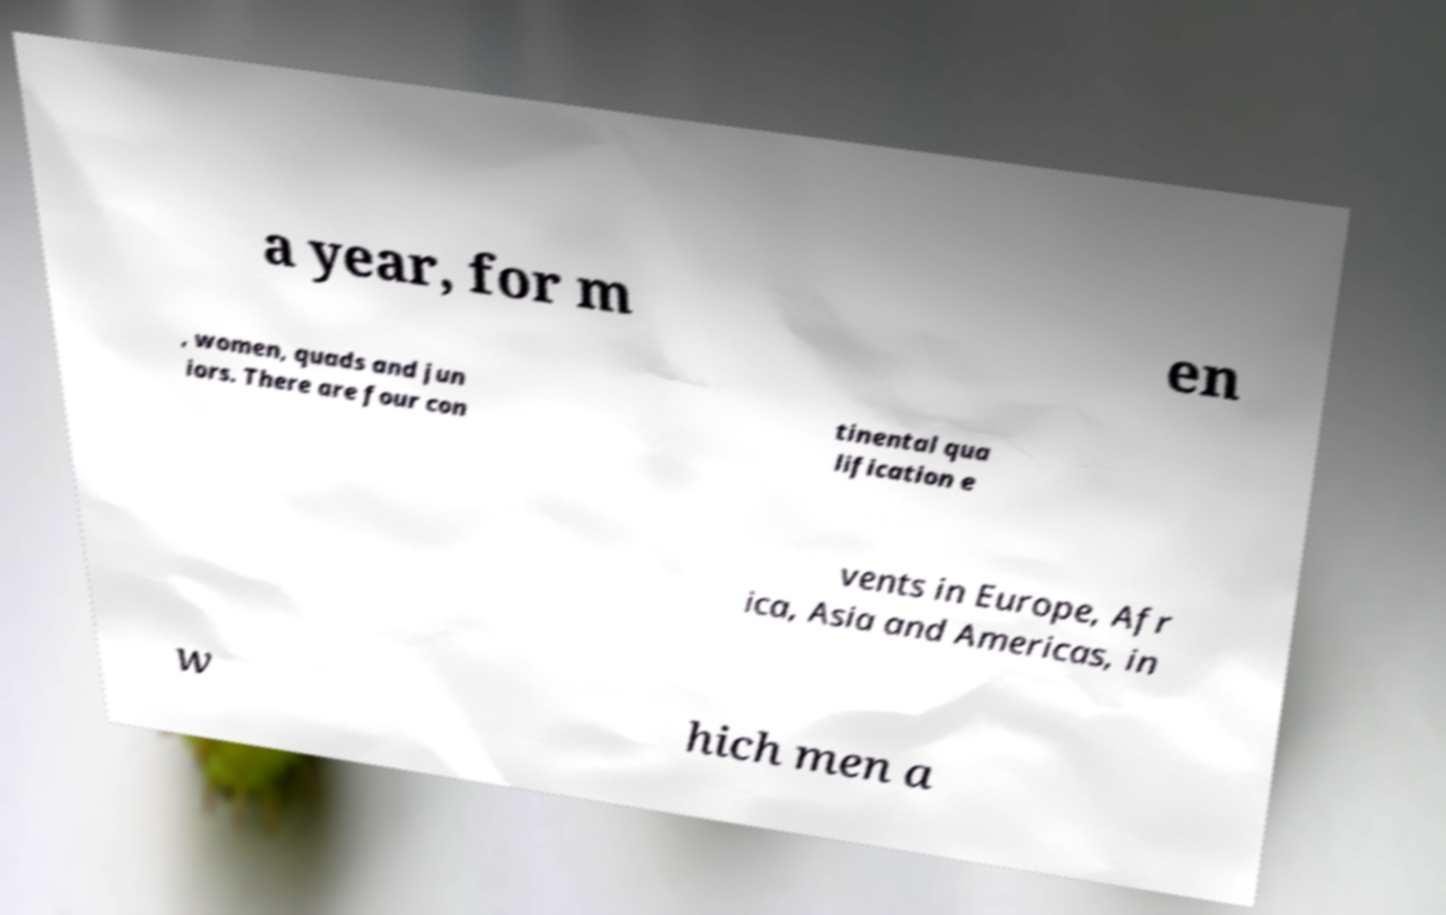What messages or text are displayed in this image? I need them in a readable, typed format. a year, for m en , women, quads and jun iors. There are four con tinental qua lification e vents in Europe, Afr ica, Asia and Americas, in w hich men a 